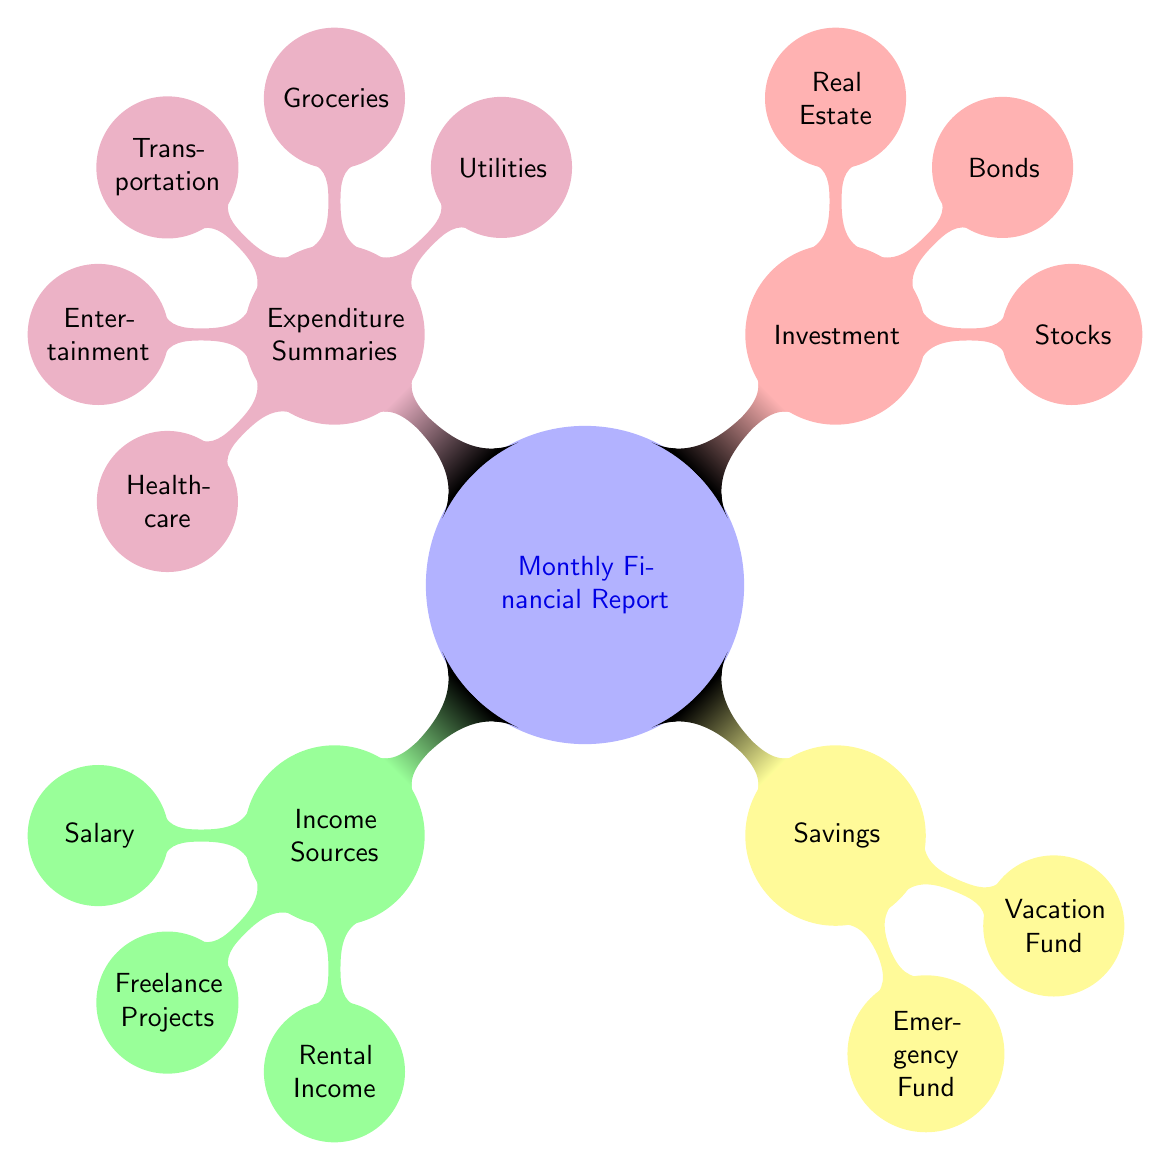What are the three income sources listed in the diagram? The diagram lists three income sources under the "Income Sources" node: Salary, Freelance Projects, and Rental Income. These are found at the first level of the diagram, directly connected to the "Income Sources" node.
Answer: Salary, Freelance Projects, Rental Income How many types of savings are there? In the "Savings" section, there are two distinct types mentioned: Emergency Fund and Vacation Fund. This can be counted directly from the nodes connected to the "Savings" node.
Answer: 2 What is the main purpose of the "Expenditure Summaries" node? The "Expenditure Summaries" node consolidates all household expenditures into a single category, offering a summary of where money is spent. The node connects to multiple subcategories such as Utilities, Groceries, Transportation, Entertainment, and Healthcare.
Answer: Summary of expenditures What types of investments are mentioned? The diagram specifies three types of investments: Stocks, Bonds, and Real Estate, which can be found connected directly to the "Investment" node. This provides a clear categorization of the investments.
Answer: Stocks, Bonds, Real Estate Which category directly supports the "Emergency Fund"? The "Emergency Fund" is a child node of the "Savings" category, indicating that it is a type of savings that is specifically designated for emergencies. This relationship can be traced from the root "Monthly Financial Report" to "Savings" then to "Emergency Fund".
Answer: Savings What is the total number of sub-categories in the "Expenditure Summaries"? There are five distinct sub-categories listed under "Expenditure Summaries": Utilities, Groceries, Transportation, Entertainment, and Healthcare. This gives a total count of the expenditures outlined in the diagram.
Answer: 5 What color represents the "Investment" section? The "Investment" section is represented in red, as indicated by the designated color coding in the diagram. This visual element helps differentiate it from other sections.
Answer: Red Which two funds are included under the "Savings" category? Under the "Savings" category, the two funds listed are the Emergency Fund and the Vacation Fund. This can be checked by looking at the nodes branching from the "Savings" node.
Answer: Emergency Fund, Vacation Fund 